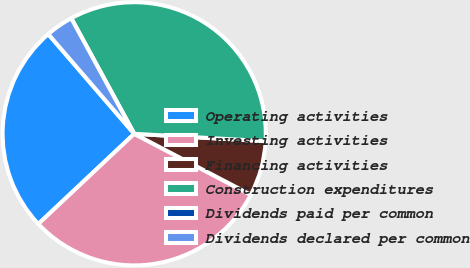<chart> <loc_0><loc_0><loc_500><loc_500><pie_chart><fcel>Operating activities<fcel>Investing activities<fcel>Financing activities<fcel>Construction expenditures<fcel>Dividends paid per common<fcel>Dividends declared per common<nl><fcel>25.69%<fcel>30.32%<fcel>6.77%<fcel>33.84%<fcel>0.0%<fcel>3.38%<nl></chart> 